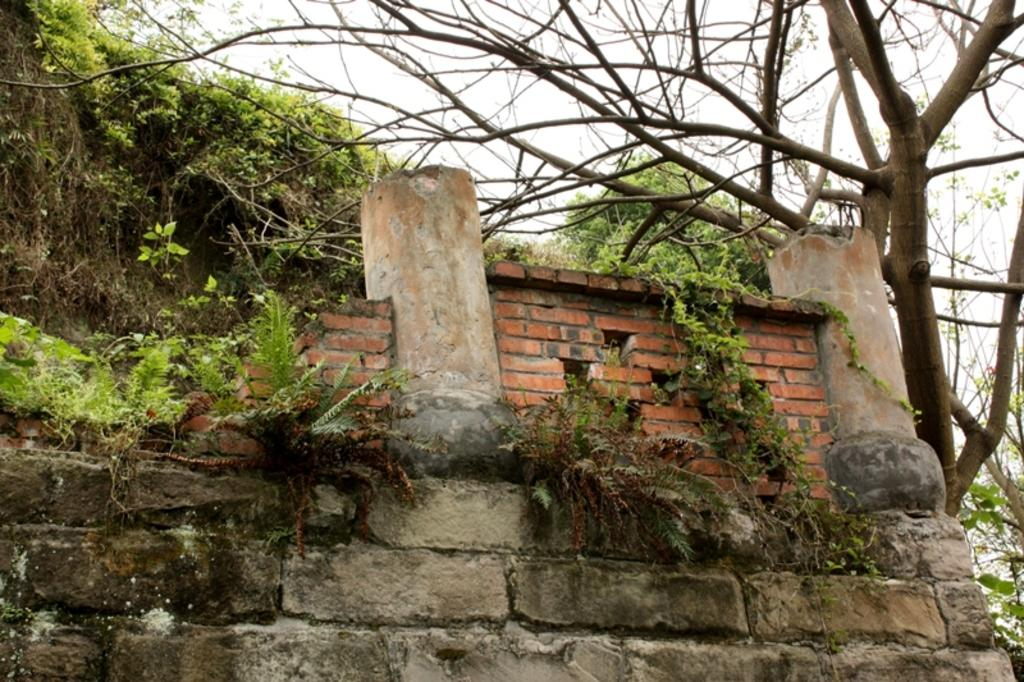What is located in the center of the image? There is a wall and two pillars in the center of the image. What other objects can be seen in the center of the image? There are a few other objects in the center of the image. What is visible in the background of the image? The sky, clouds, trees, and plants are visible in the background of the image. How many cows are present in the image? There are no cows present in the image. What type of agreement is being made in the image? There is no indication of an agreement being made in the image. 